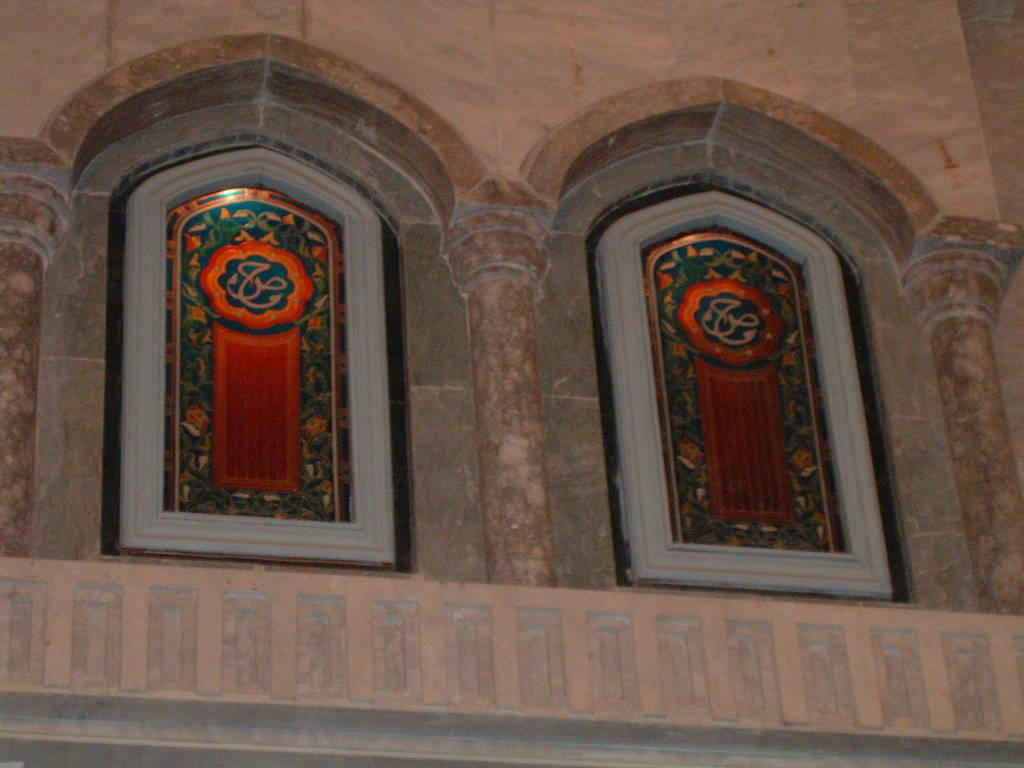What type of glass can be seen in the image? There are stained glasses in the image. What might be the purpose of the stained glasses in the image? Stained glasses are often used for decorative or artistic purposes, so they might be decorating a window or a piece of furniture. Can you see any kitties playing with the veins in the image? There are no kitties or veins present in the image; it only features stained glasses. 